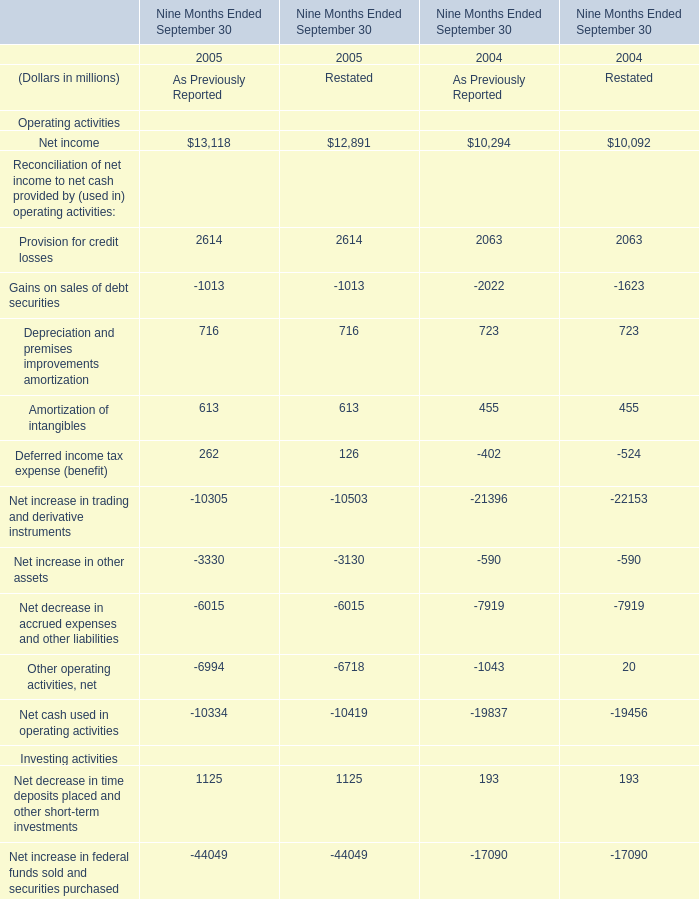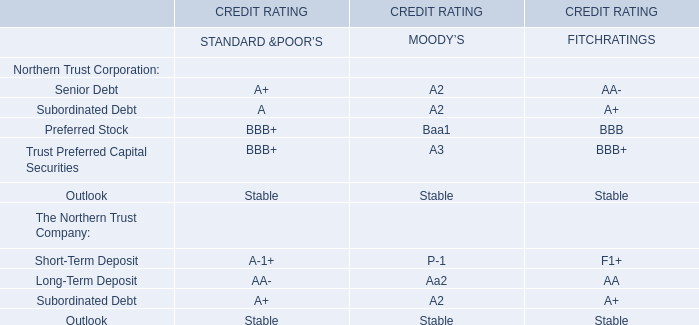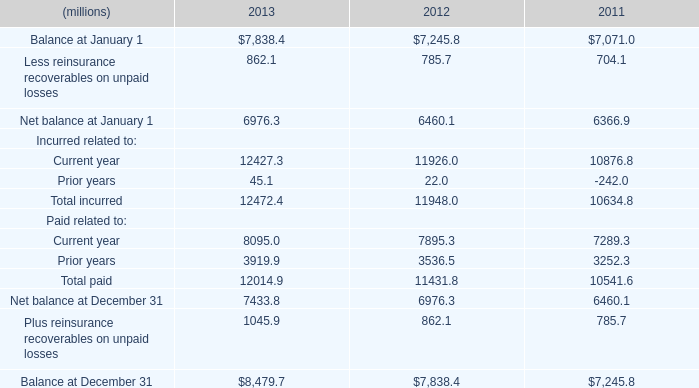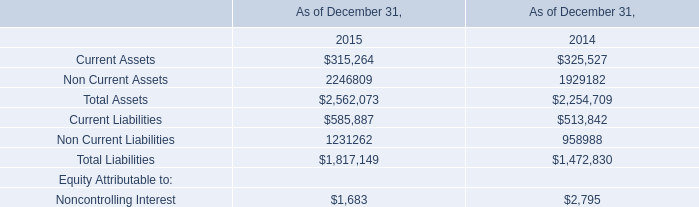What is the average amount of Current Liabilities of As of December 31, 2015, and Balance at January 1 of 2012 ? 
Computations: ((585887.0 + 7245.8) / 2)
Answer: 296566.4. 